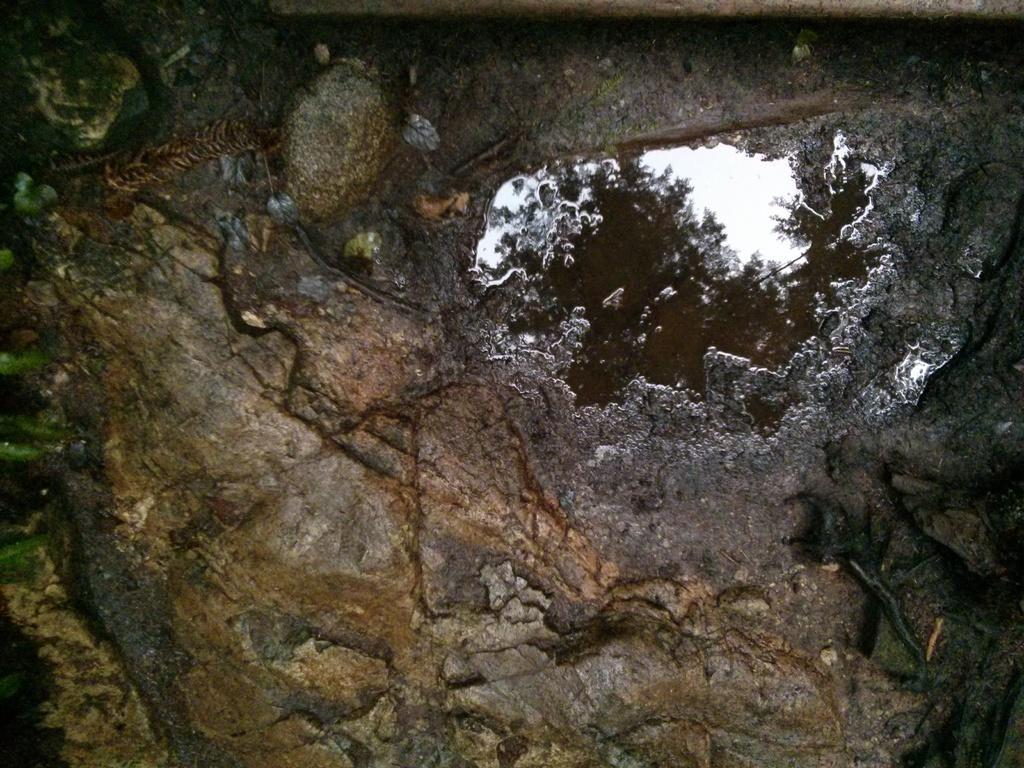Could you give a brief overview of what you see in this image? In the picture we can see the surface of the rock, on it we can see some water, in it we can see the reflection of the tree and the sky. 